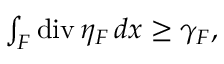<formula> <loc_0><loc_0><loc_500><loc_500>\begin{array} { r } { \int _ { F } d i v \, \eta _ { F } \, d x \geq \gamma _ { F } , } \end{array}</formula> 